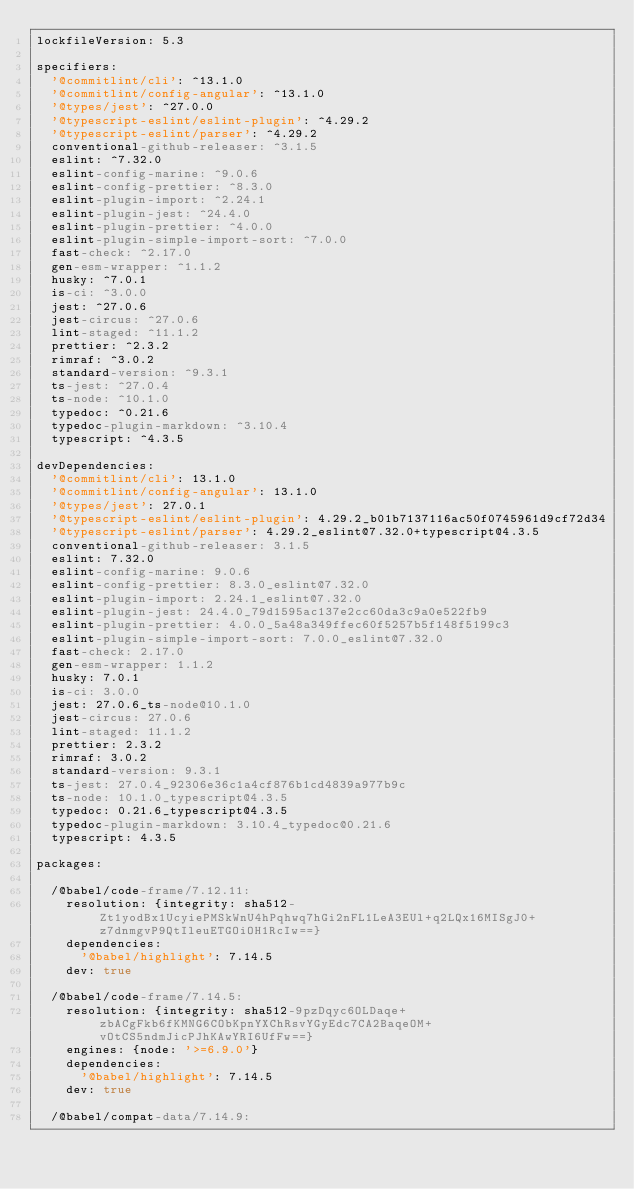<code> <loc_0><loc_0><loc_500><loc_500><_YAML_>lockfileVersion: 5.3

specifiers:
  '@commitlint/cli': ^13.1.0
  '@commitlint/config-angular': ^13.1.0
  '@types/jest': ^27.0.0
  '@typescript-eslint/eslint-plugin': ^4.29.2
  '@typescript-eslint/parser': ^4.29.2
  conventional-github-releaser: ^3.1.5
  eslint: ^7.32.0
  eslint-config-marine: ^9.0.6
  eslint-config-prettier: ^8.3.0
  eslint-plugin-import: ^2.24.1
  eslint-plugin-jest: ^24.4.0
  eslint-plugin-prettier: ^4.0.0
  eslint-plugin-simple-import-sort: ^7.0.0
  fast-check: ^2.17.0
  gen-esm-wrapper: ^1.1.2
  husky: ^7.0.1
  is-ci: ^3.0.0
  jest: ^27.0.6
  jest-circus: ^27.0.6
  lint-staged: ^11.1.2
  prettier: ^2.3.2
  rimraf: ^3.0.2
  standard-version: ^9.3.1
  ts-jest: ^27.0.4
  ts-node: ^10.1.0
  typedoc: ^0.21.6
  typedoc-plugin-markdown: ^3.10.4
  typescript: ^4.3.5

devDependencies:
  '@commitlint/cli': 13.1.0
  '@commitlint/config-angular': 13.1.0
  '@types/jest': 27.0.1
  '@typescript-eslint/eslint-plugin': 4.29.2_b01b7137116ac50f0745961d9cf72d34
  '@typescript-eslint/parser': 4.29.2_eslint@7.32.0+typescript@4.3.5
  conventional-github-releaser: 3.1.5
  eslint: 7.32.0
  eslint-config-marine: 9.0.6
  eslint-config-prettier: 8.3.0_eslint@7.32.0
  eslint-plugin-import: 2.24.1_eslint@7.32.0
  eslint-plugin-jest: 24.4.0_79d1595ac137e2cc60da3c9a0e522fb9
  eslint-plugin-prettier: 4.0.0_5a48a349ffec60f5257b5f148f5199c3
  eslint-plugin-simple-import-sort: 7.0.0_eslint@7.32.0
  fast-check: 2.17.0
  gen-esm-wrapper: 1.1.2
  husky: 7.0.1
  is-ci: 3.0.0
  jest: 27.0.6_ts-node@10.1.0
  jest-circus: 27.0.6
  lint-staged: 11.1.2
  prettier: 2.3.2
  rimraf: 3.0.2
  standard-version: 9.3.1
  ts-jest: 27.0.4_92306e36c1a4cf876b1cd4839a977b9c
  ts-node: 10.1.0_typescript@4.3.5
  typedoc: 0.21.6_typescript@4.3.5
  typedoc-plugin-markdown: 3.10.4_typedoc@0.21.6
  typescript: 4.3.5

packages:

  /@babel/code-frame/7.12.11:
    resolution: {integrity: sha512-Zt1yodBx1UcyiePMSkWnU4hPqhwq7hGi2nFL1LeA3EUl+q2LQx16MISgJ0+z7dnmgvP9QtIleuETGOiOH1RcIw==}
    dependencies:
      '@babel/highlight': 7.14.5
    dev: true

  /@babel/code-frame/7.14.5:
    resolution: {integrity: sha512-9pzDqyc6OLDaqe+zbACgFkb6fKMNG6CObKpnYXChRsvYGyEdc7CA2BaqeOM+vOtCS5ndmJicPJhKAwYRI6UfFw==}
    engines: {node: '>=6.9.0'}
    dependencies:
      '@babel/highlight': 7.14.5
    dev: true

  /@babel/compat-data/7.14.9:</code> 